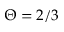Convert formula to latex. <formula><loc_0><loc_0><loc_500><loc_500>\Theta = 2 / 3</formula> 